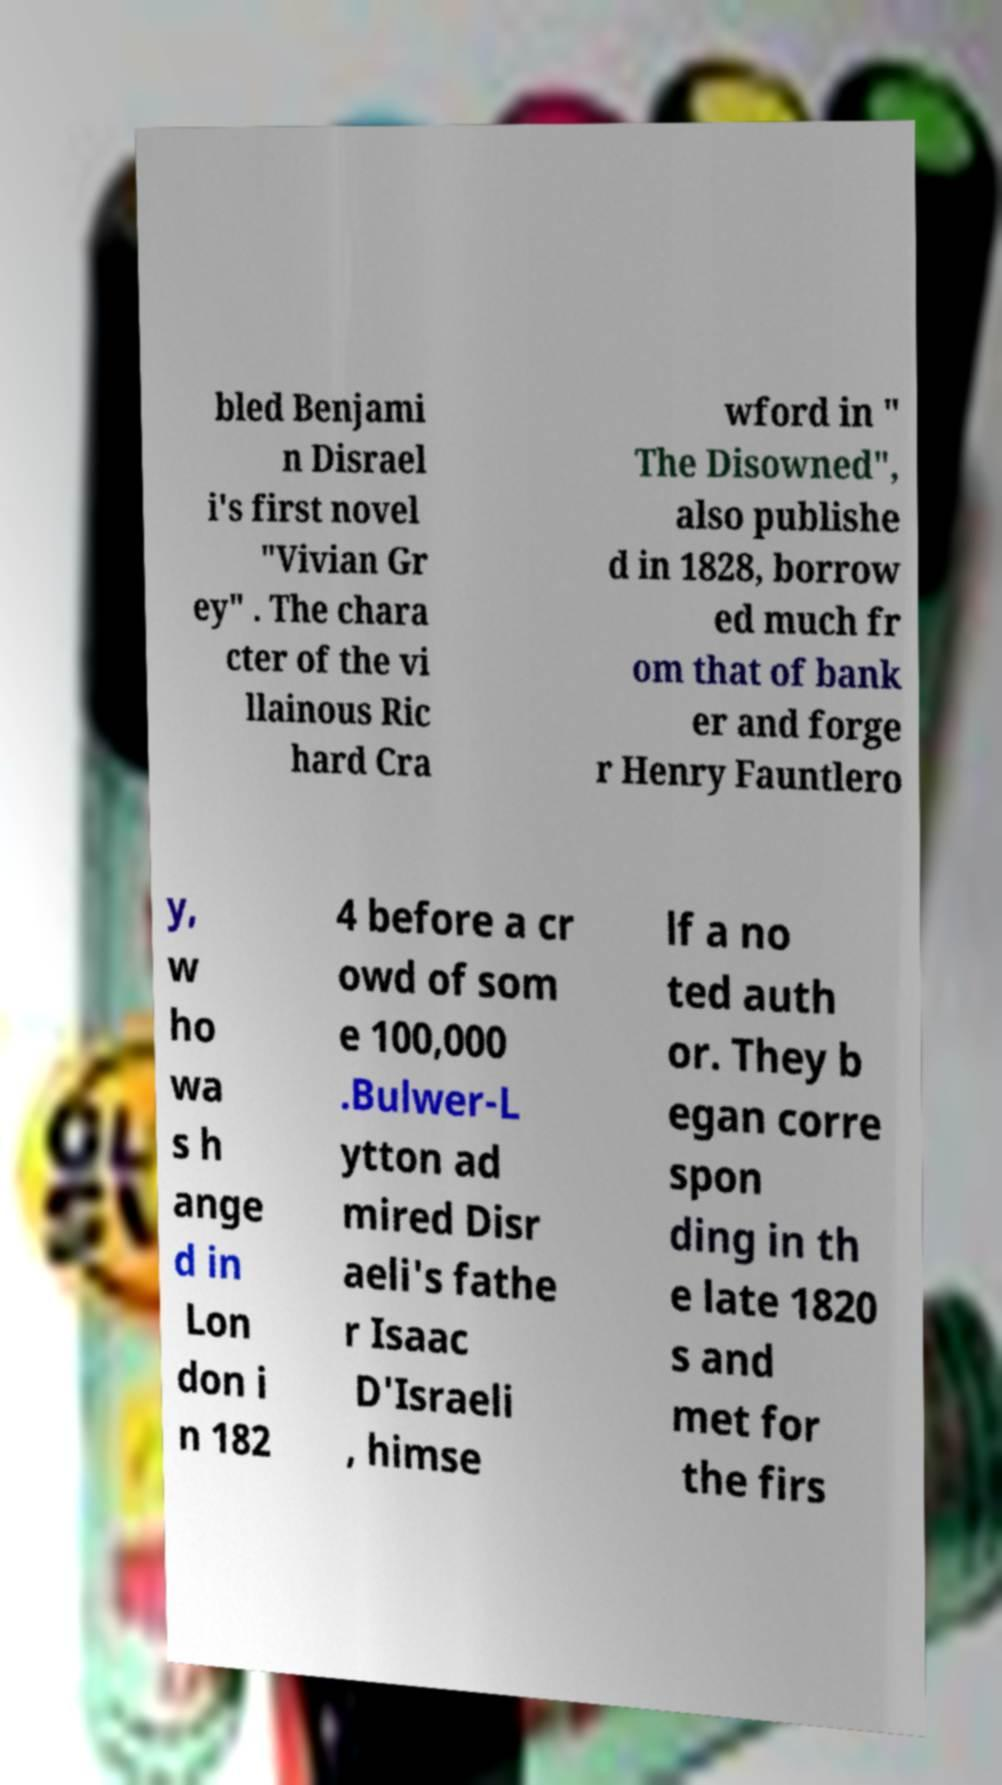Could you extract and type out the text from this image? bled Benjami n Disrael i's first novel "Vivian Gr ey" . The chara cter of the vi llainous Ric hard Cra wford in " The Disowned", also publishe d in 1828, borrow ed much fr om that of bank er and forge r Henry Fauntlero y, w ho wa s h ange d in Lon don i n 182 4 before a cr owd of som e 100,000 .Bulwer-L ytton ad mired Disr aeli's fathe r Isaac D'Israeli , himse lf a no ted auth or. They b egan corre spon ding in th e late 1820 s and met for the firs 